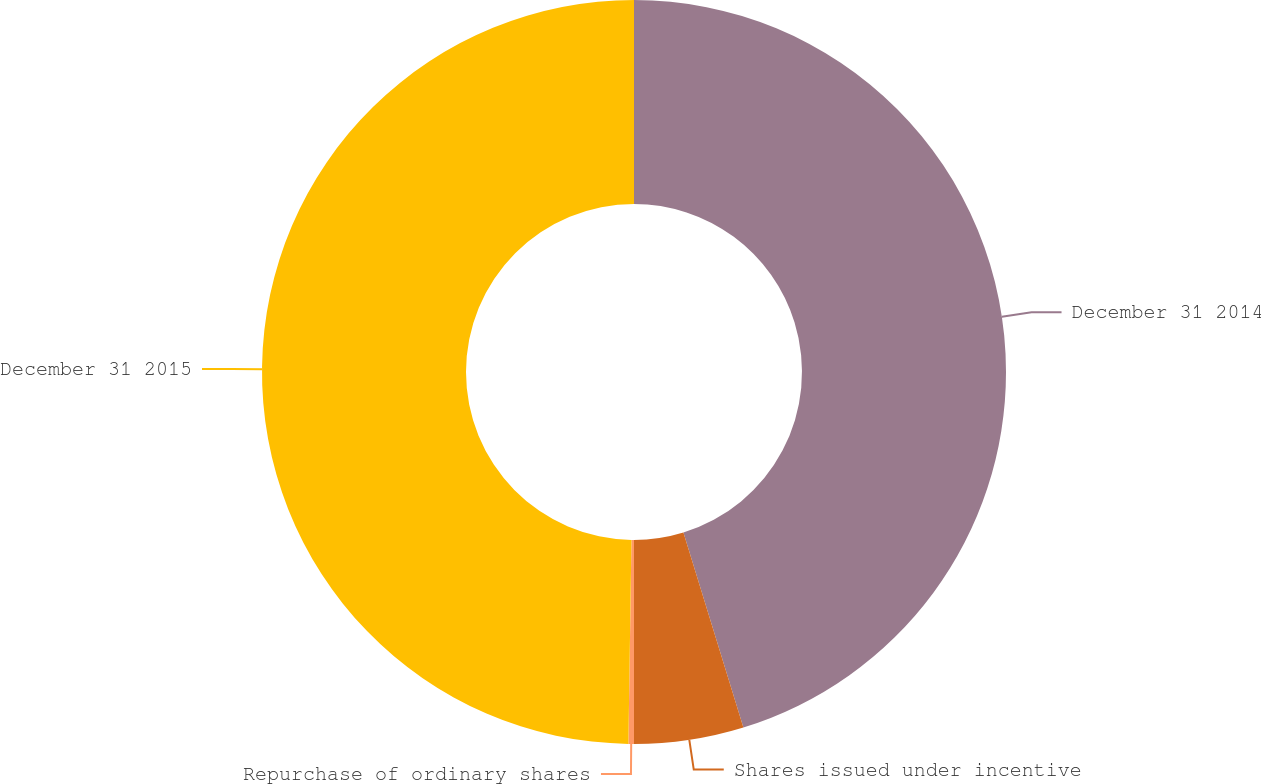<chart> <loc_0><loc_0><loc_500><loc_500><pie_chart><fcel>December 31 2014<fcel>Shares issued under incentive<fcel>Repurchase of ordinary shares<fcel>December 31 2015<nl><fcel>45.25%<fcel>4.75%<fcel>0.24%<fcel>49.76%<nl></chart> 